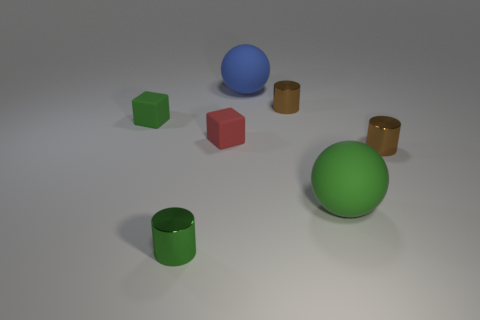Subtract all yellow spheres. How many brown cylinders are left? 2 Add 1 green rubber objects. How many objects exist? 8 Subtract all cylinders. How many objects are left? 4 Subtract all green cylinders. Subtract all brown matte blocks. How many objects are left? 6 Add 3 brown shiny cylinders. How many brown shiny cylinders are left? 5 Add 1 red rubber things. How many red rubber things exist? 2 Subtract 1 green balls. How many objects are left? 6 